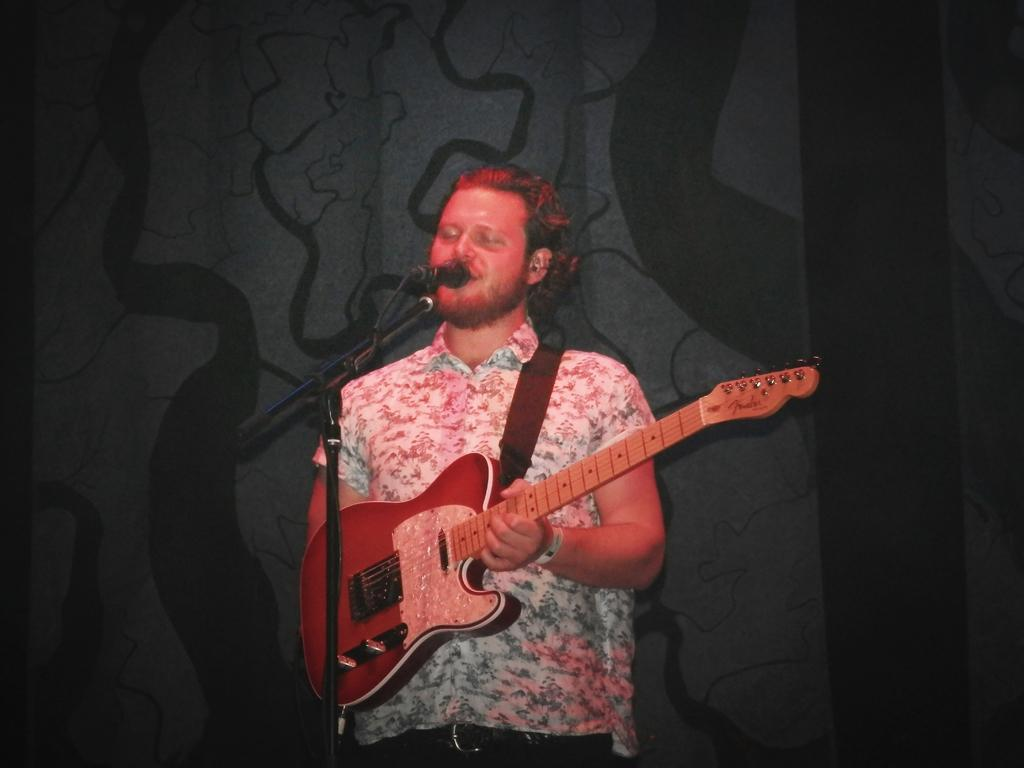What is the man in the image doing? The man is standing in the image and singing. What is the man holding in his hands? The man is holding a guitar in his hands. What object is present in the image that is typically used for amplifying sound? There is a microphone in the image. What is the microphone attached to in the image? The microphone is attached to a microphone stand in the image. Where is the woman riding her bike in the park in the image? There is no woman riding a bike in the park in the image; it only features a man singing with a guitar and a microphone. 